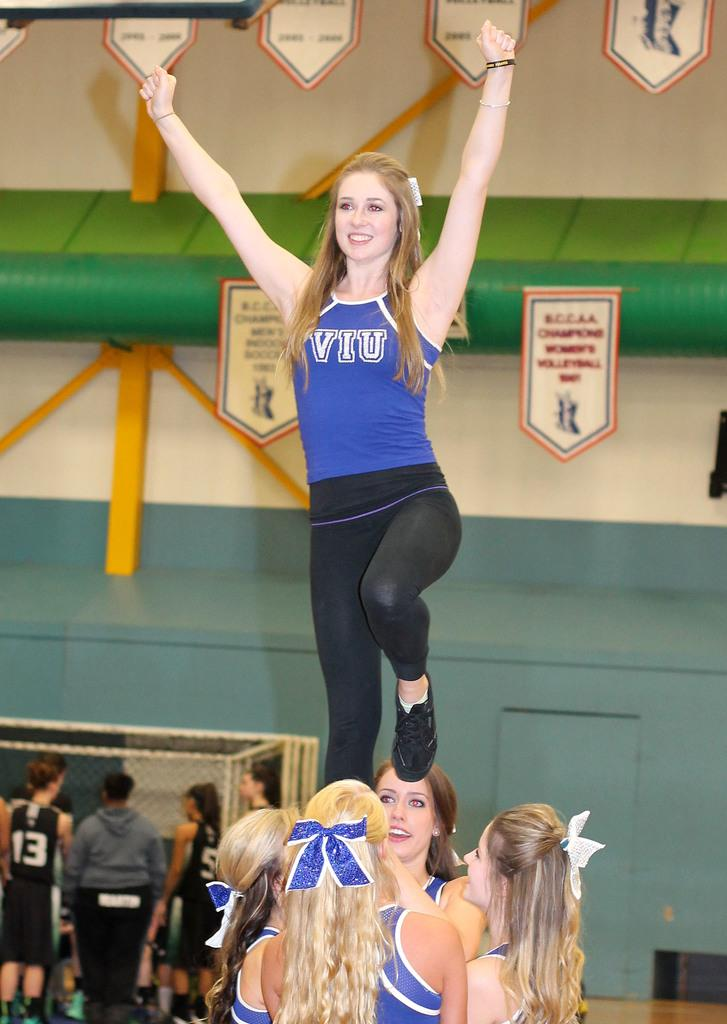Provide a one-sentence caption for the provided image. A cheerleader for VIU is held up in a pyramid. 